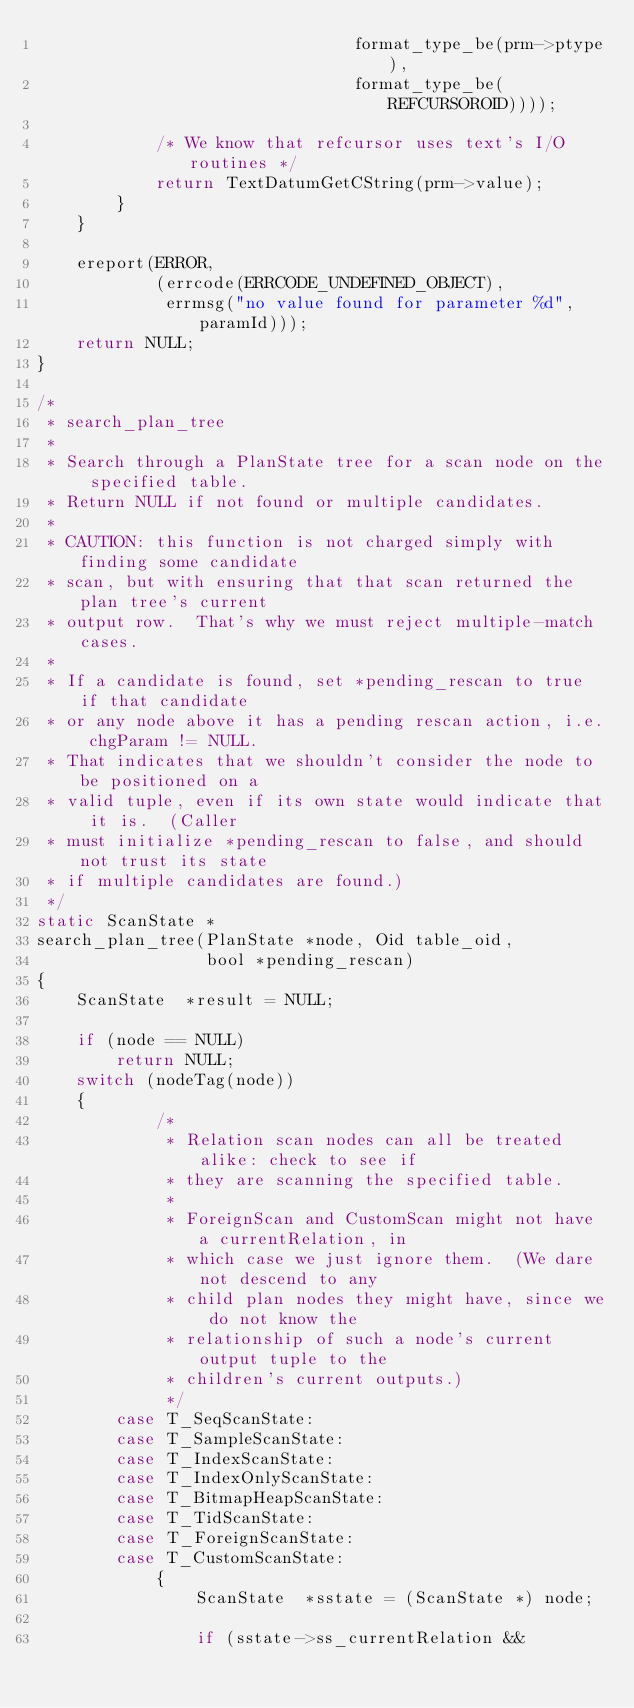<code> <loc_0><loc_0><loc_500><loc_500><_C_>								format_type_be(prm->ptype),
								format_type_be(REFCURSOROID))));

			/* We know that refcursor uses text's I/O routines */
			return TextDatumGetCString(prm->value);
		}
	}

	ereport(ERROR,
			(errcode(ERRCODE_UNDEFINED_OBJECT),
			 errmsg("no value found for parameter %d", paramId)));
	return NULL;
}

/*
 * search_plan_tree
 *
 * Search through a PlanState tree for a scan node on the specified table.
 * Return NULL if not found or multiple candidates.
 *
 * CAUTION: this function is not charged simply with finding some candidate
 * scan, but with ensuring that that scan returned the plan tree's current
 * output row.  That's why we must reject multiple-match cases.
 *
 * If a candidate is found, set *pending_rescan to true if that candidate
 * or any node above it has a pending rescan action, i.e. chgParam != NULL.
 * That indicates that we shouldn't consider the node to be positioned on a
 * valid tuple, even if its own state would indicate that it is.  (Caller
 * must initialize *pending_rescan to false, and should not trust its state
 * if multiple candidates are found.)
 */
static ScanState *
search_plan_tree(PlanState *node, Oid table_oid,
				 bool *pending_rescan)
{
	ScanState  *result = NULL;

	if (node == NULL)
		return NULL;
	switch (nodeTag(node))
	{
			/*
			 * Relation scan nodes can all be treated alike: check to see if
			 * they are scanning the specified table.
			 *
			 * ForeignScan and CustomScan might not have a currentRelation, in
			 * which case we just ignore them.  (We dare not descend to any
			 * child plan nodes they might have, since we do not know the
			 * relationship of such a node's current output tuple to the
			 * children's current outputs.)
			 */
		case T_SeqScanState:
		case T_SampleScanState:
		case T_IndexScanState:
		case T_IndexOnlyScanState:
		case T_BitmapHeapScanState:
		case T_TidScanState:
		case T_ForeignScanState:
		case T_CustomScanState:
			{
				ScanState  *sstate = (ScanState *) node;

				if (sstate->ss_currentRelation &&</code> 